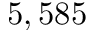Convert formula to latex. <formula><loc_0><loc_0><loc_500><loc_500>5 , 5 8 5</formula> 